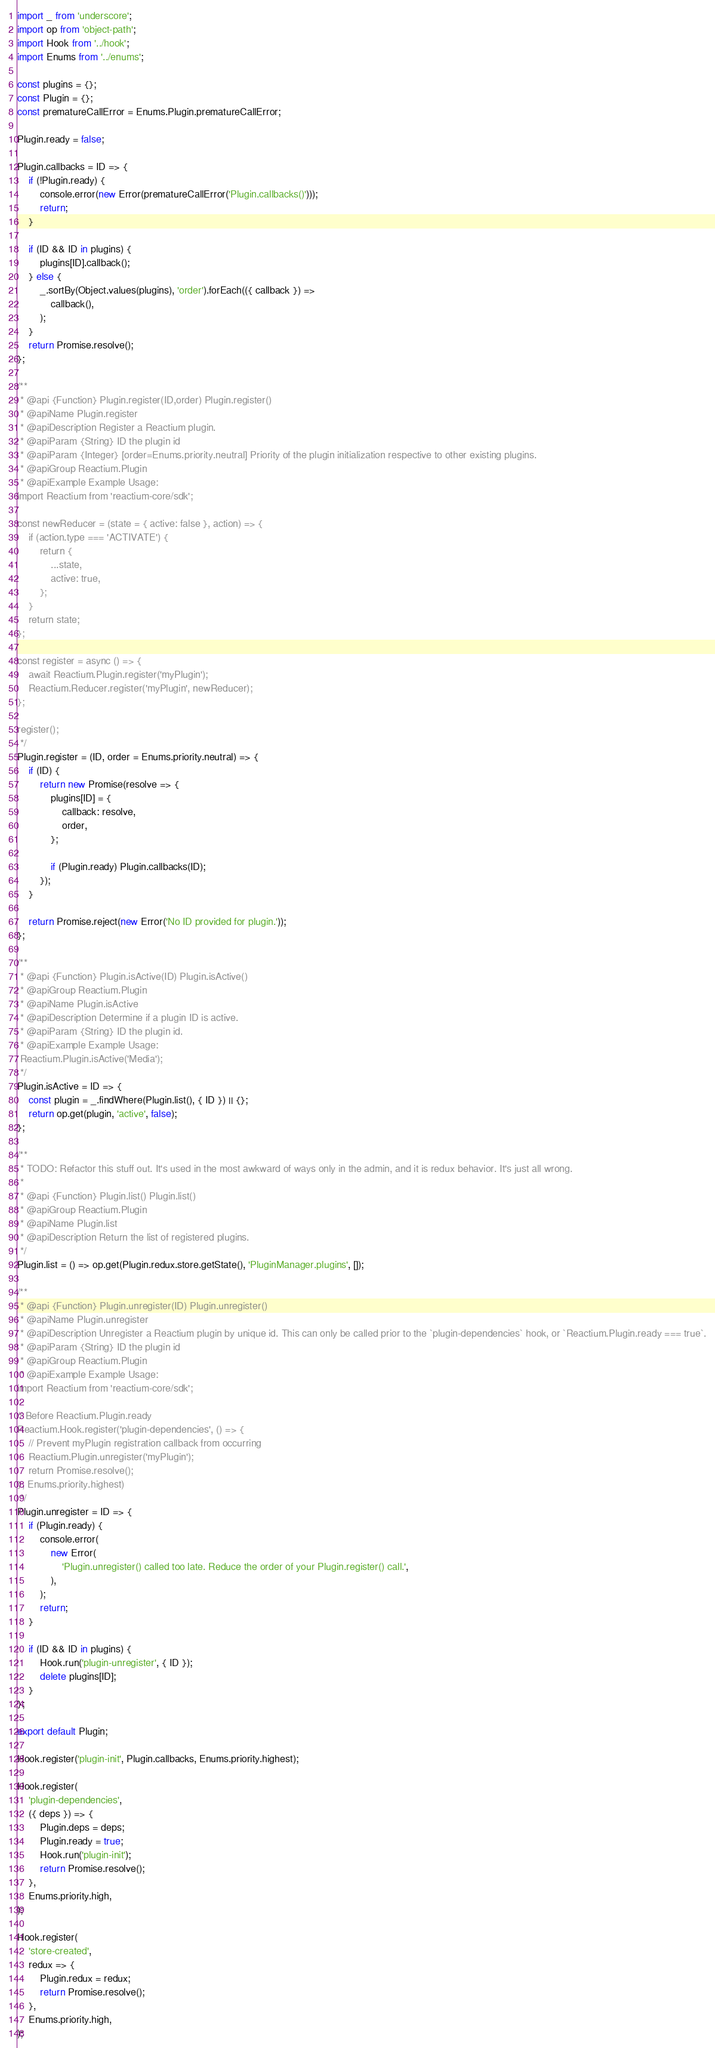Convert code to text. <code><loc_0><loc_0><loc_500><loc_500><_JavaScript_>import _ from 'underscore';
import op from 'object-path';
import Hook from '../hook';
import Enums from '../enums';

const plugins = {};
const Plugin = {};
const prematureCallError = Enums.Plugin.prematureCallError;

Plugin.ready = false;

Plugin.callbacks = ID => {
    if (!Plugin.ready) {
        console.error(new Error(prematureCallError('Plugin.callbacks()')));
        return;
    }

    if (ID && ID in plugins) {
        plugins[ID].callback();
    } else {
        _.sortBy(Object.values(plugins), 'order').forEach(({ callback }) =>
            callback(),
        );
    }
    return Promise.resolve();
};

/**
 * @api {Function} Plugin.register(ID,order) Plugin.register()
 * @apiName Plugin.register
 * @apiDescription Register a Reactium plugin.
 * @apiParam {String} ID the plugin id
 * @apiParam {Integer} [order=Enums.priority.neutral] Priority of the plugin initialization respective to other existing plugins.
 * @apiGroup Reactium.Plugin
 * @apiExample Example Usage:
import Reactium from 'reactium-core/sdk';

const newReducer = (state = { active: false }, action) => {
    if (action.type === 'ACTIVATE') {
        return {
            ...state,
            active: true,
        };
    }
    return state;
};

const register = async () => {
    await Reactium.Plugin.register('myPlugin');
    Reactium.Reducer.register('myPlugin', newReducer);
};

register();
 */
Plugin.register = (ID, order = Enums.priority.neutral) => {
    if (ID) {
        return new Promise(resolve => {
            plugins[ID] = {
                callback: resolve,
                order,
            };

            if (Plugin.ready) Plugin.callbacks(ID);
        });
    }

    return Promise.reject(new Error('No ID provided for plugin.'));
};

/**
 * @api {Function} Plugin.isActive(ID) Plugin.isActive()
 * @apiGroup Reactium.Plugin
 * @apiName Plugin.isActive
 * @apiDescription Determine if a plugin ID is active.
 * @apiParam {String} ID the plugin id.
 * @apiExample Example Usage:
 Reactium.Plugin.isActive('Media');
 */
Plugin.isActive = ID => {
    const plugin = _.findWhere(Plugin.list(), { ID }) || {};
    return op.get(plugin, 'active', false);
};

/**
 * TODO: Refactor this stuff out. It's used in the most awkward of ways only in the admin, and it is redux behavior. It's just all wrong.
 * 
 * @api {Function} Plugin.list() Plugin.list()
 * @apiGroup Reactium.Plugin
 * @apiName Plugin.list
 * @apiDescription Return the list of registered plugins.
 */
Plugin.list = () => op.get(Plugin.redux.store.getState(), 'PluginManager.plugins', []);

/**
 * @api {Function} Plugin.unregister(ID) Plugin.unregister()
 * @apiName Plugin.unregister
 * @apiDescription Unregister a Reactium plugin by unique id. This can only be called prior to the `plugin-dependencies` hook, or `Reactium.Plugin.ready === true`.
 * @apiParam {String} ID the plugin id
 * @apiGroup Reactium.Plugin
 * @apiExample Example Usage:
import Reactium from 'reactium-core/sdk';

// Before Reactium.Plugin.ready
Reactium.Hook.register('plugin-dependencies', () => {
    // Prevent myPlugin registration callback from occurring
    Reactium.Plugin.unregister('myPlugin');
    return Promise.resolve();
}, Enums.priority.highest)
 */
Plugin.unregister = ID => {
    if (Plugin.ready) {
        console.error(
            new Error(
                'Plugin.unregister() called too late. Reduce the order of your Plugin.register() call.',
            ),
        );
        return;
    }

    if (ID && ID in plugins) {
        Hook.run('plugin-unregister', { ID });
        delete plugins[ID];
    }
};

export default Plugin;

Hook.register('plugin-init', Plugin.callbacks, Enums.priority.highest);

Hook.register(
    'plugin-dependencies',
    ({ deps }) => {
        Plugin.deps = deps;
        Plugin.ready = true;
        Hook.run('plugin-init');
        return Promise.resolve();
    },
    Enums.priority.high,
);

Hook.register(
    'store-created',
    redux => {
        Plugin.redux = redux;
        return Promise.resolve();
    },
    Enums.priority.high,
);
</code> 